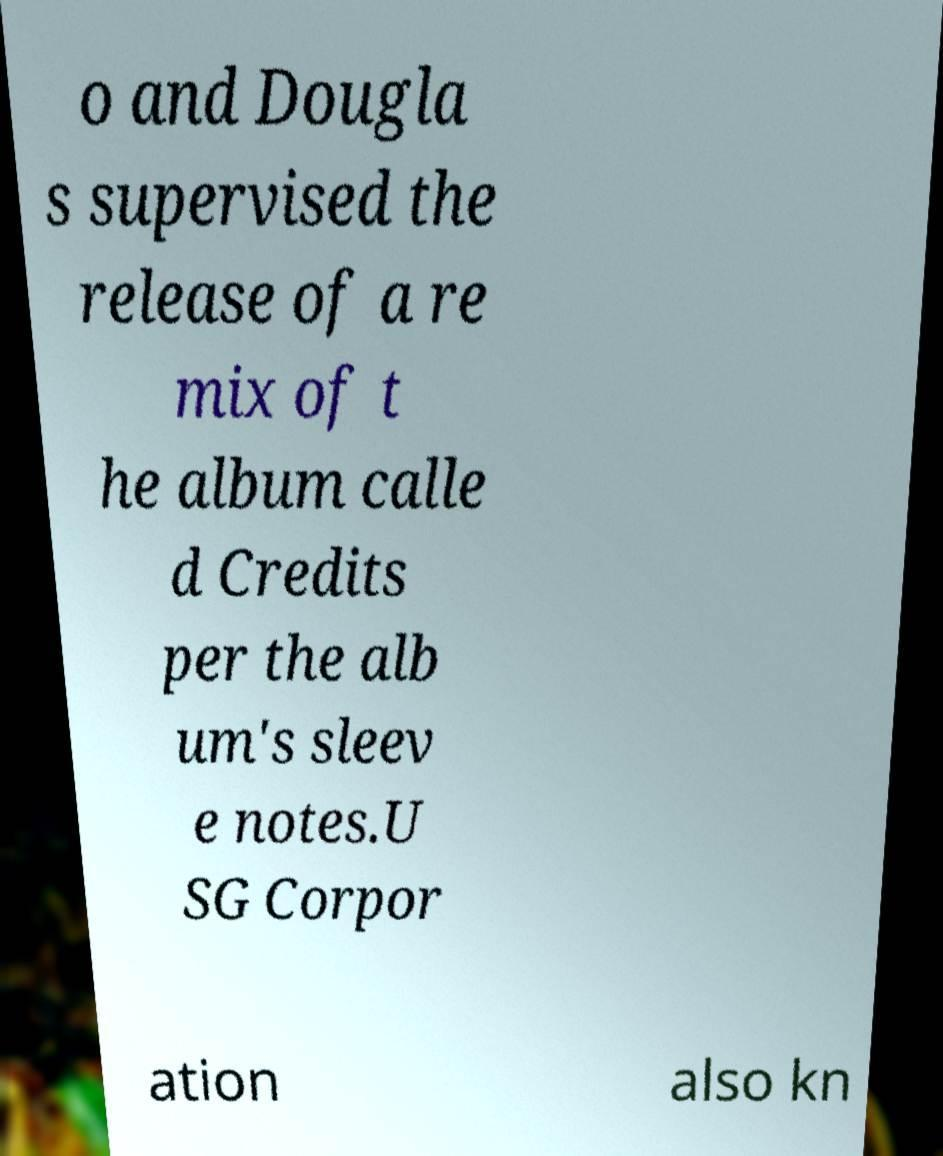For documentation purposes, I need the text within this image transcribed. Could you provide that? o and Dougla s supervised the release of a re mix of t he album calle d Credits per the alb um's sleev e notes.U SG Corpor ation also kn 